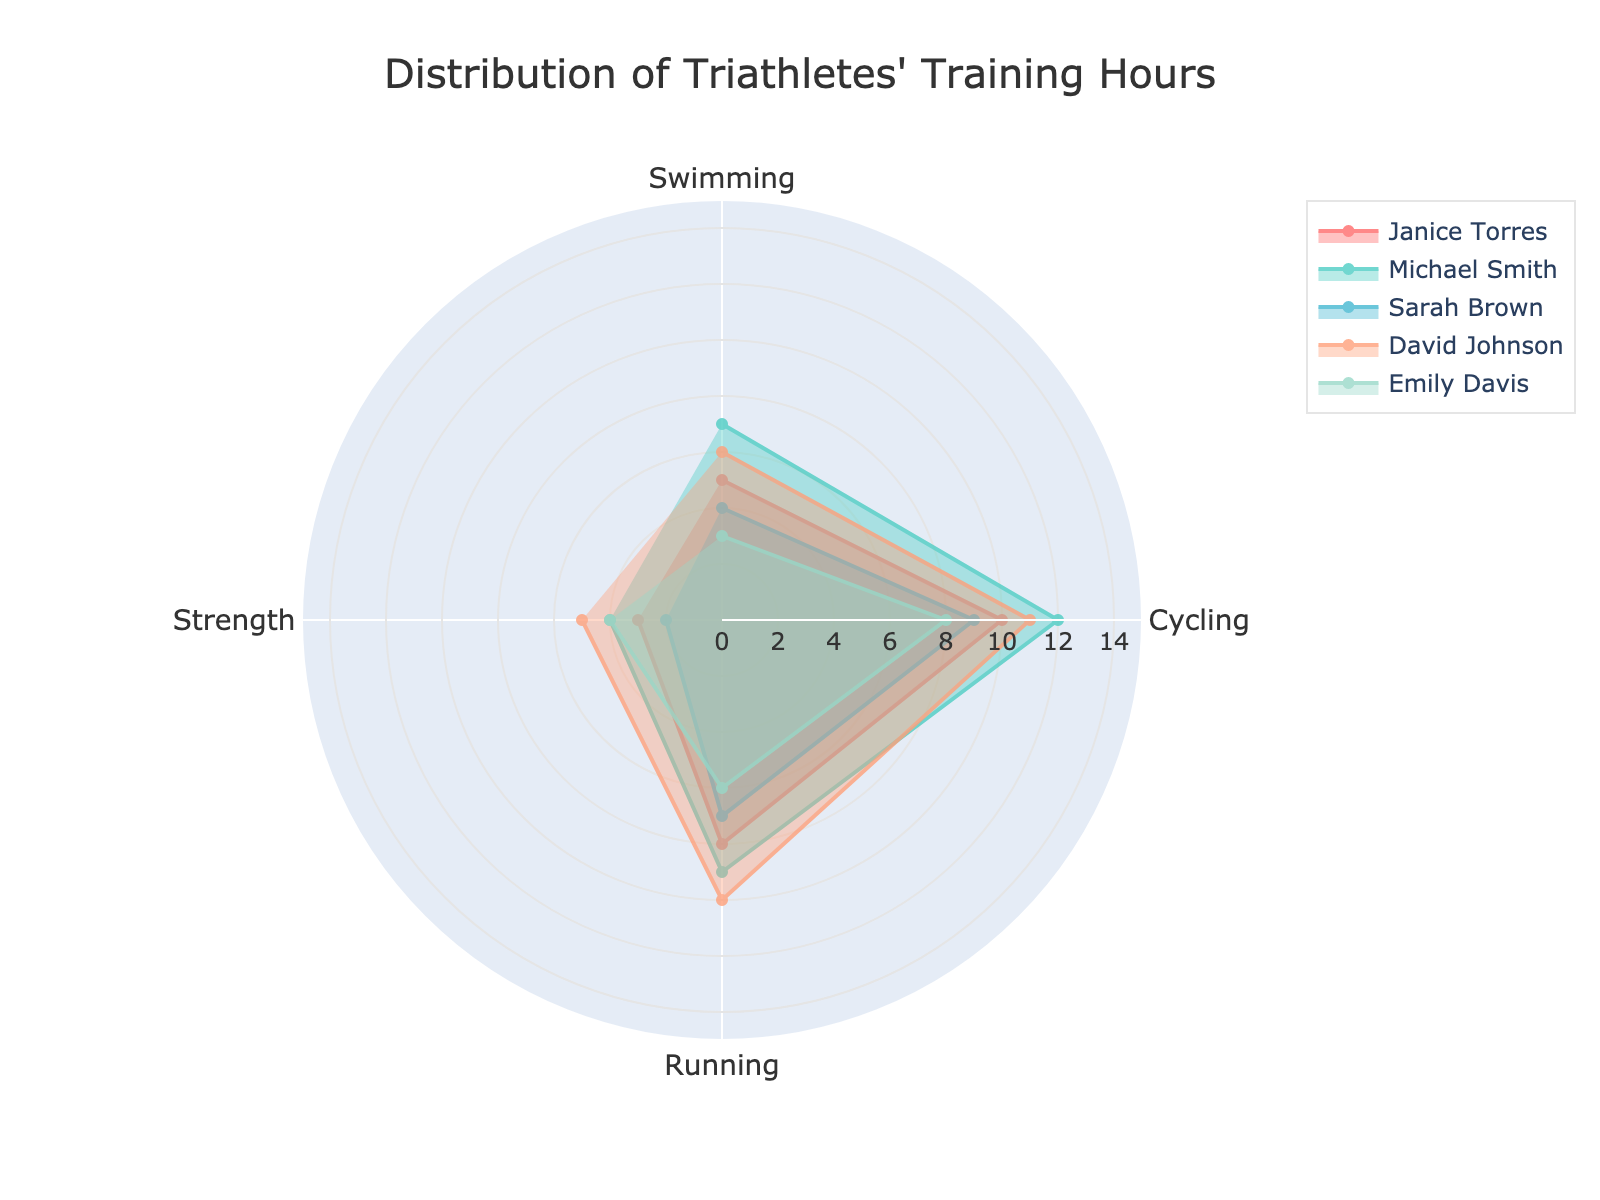What is the title of the figure? The title of the figure is typically placed at the top center of the chart layout. In this specific plot, the title should be fairly prominent and easy to identify.
Answer: Distribution of Triathletes' Training Hours How many training aspects are shown in the chart? The training aspects are represented by the different categories or axes on the polar chart. By counting them, we can determine the total number of distinct aspects.
Answer: 4 What color represents Michael Smith's data? Each athlete's data is represented by a distinct color on the chart. Michael Smith's data is represented by one of these colors. On the chart, colors are used consistently to allow quick identification.
Answer: Light turquoise Which triathlete has the highest number of training hours in running? To find this information, we need to look at the running category on the polar chart and identify the athlete with the largest value in that section.
Answer: David Johnson How does Janice Torres' training time for cycling compare to her strength training? This requires examining both the cycling and strength training sections for Janice Torres and comparing the values shown.
Answer: Higher for cycling What is the average number of swimming hours for all triathletes? Add the swimming hours for all triathletes (5 + 7 + 4 + 6 + 3) and then divide by the number of triathletes (5) to get the average.
Answer: 5 Which athlete has the most balanced training schedule, considering all aspects? This question requires observing each athlete's data across all training aspects and identifying the one with the least variance between different aspects. A balanced schedule means less pronounced peaks and troughs.
Answer: Emily Davis What are the lowest and highest values for strength training recorded in the chart? To answer this, check the strength category for each athlete, and identify the smallest and largest values listed.
Answer: Lowest: 2, Highest: 5 Which training aspect has the most variation in hours among the triathletes? Variation can be assessed by looking at the range of values for each training aspect. The aspect with the widest range has the most variation.
Answer: Swimming How do Sarah Brown's training hours in swimming compare to her hours in running? Check the polar chart for Sarah Brown's data points for both swimming and running and compare the values directly.
Answer: Lower in swimming 